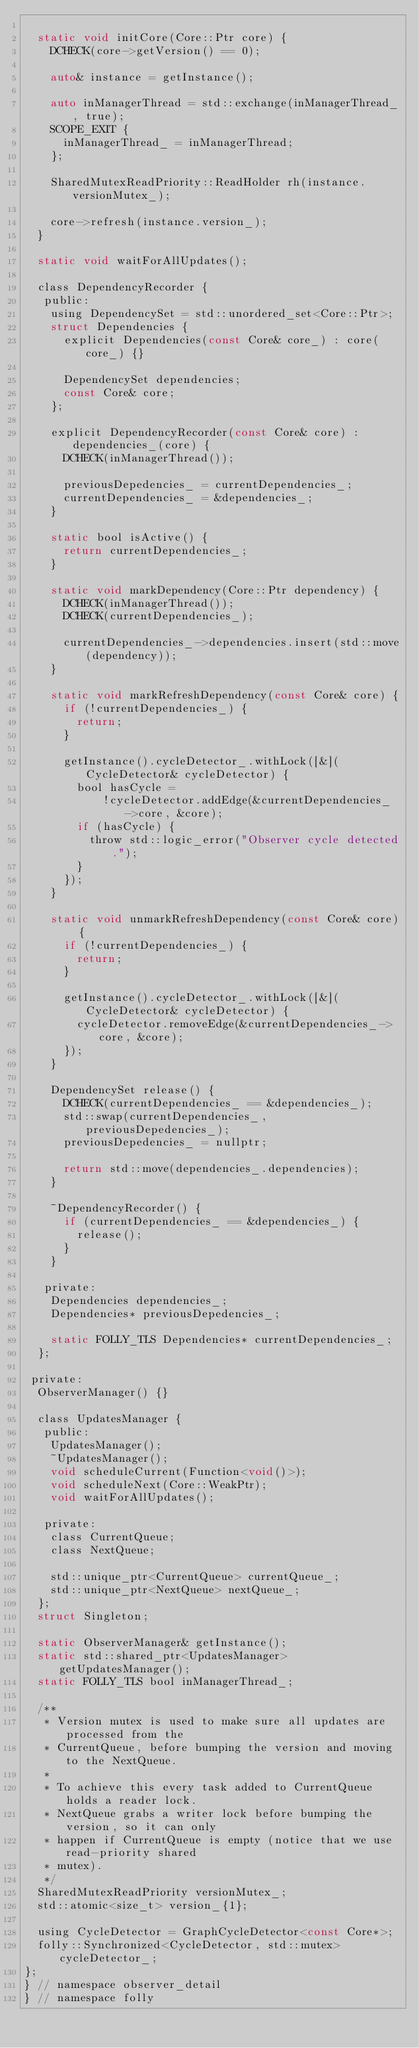Convert code to text. <code><loc_0><loc_0><loc_500><loc_500><_C_>
  static void initCore(Core::Ptr core) {
    DCHECK(core->getVersion() == 0);

    auto& instance = getInstance();

    auto inManagerThread = std::exchange(inManagerThread_, true);
    SCOPE_EXIT {
      inManagerThread_ = inManagerThread;
    };

    SharedMutexReadPriority::ReadHolder rh(instance.versionMutex_);

    core->refresh(instance.version_);
  }

  static void waitForAllUpdates();

  class DependencyRecorder {
   public:
    using DependencySet = std::unordered_set<Core::Ptr>;
    struct Dependencies {
      explicit Dependencies(const Core& core_) : core(core_) {}

      DependencySet dependencies;
      const Core& core;
    };

    explicit DependencyRecorder(const Core& core) : dependencies_(core) {
      DCHECK(inManagerThread());

      previousDepedencies_ = currentDependencies_;
      currentDependencies_ = &dependencies_;
    }

    static bool isActive() {
      return currentDependencies_;
    }

    static void markDependency(Core::Ptr dependency) {
      DCHECK(inManagerThread());
      DCHECK(currentDependencies_);

      currentDependencies_->dependencies.insert(std::move(dependency));
    }

    static void markRefreshDependency(const Core& core) {
      if (!currentDependencies_) {
        return;
      }

      getInstance().cycleDetector_.withLock([&](CycleDetector& cycleDetector) {
        bool hasCycle =
            !cycleDetector.addEdge(&currentDependencies_->core, &core);
        if (hasCycle) {
          throw std::logic_error("Observer cycle detected.");
        }
      });
    }

    static void unmarkRefreshDependency(const Core& core) {
      if (!currentDependencies_) {
        return;
      }

      getInstance().cycleDetector_.withLock([&](CycleDetector& cycleDetector) {
        cycleDetector.removeEdge(&currentDependencies_->core, &core);
      });
    }

    DependencySet release() {
      DCHECK(currentDependencies_ == &dependencies_);
      std::swap(currentDependencies_, previousDepedencies_);
      previousDepedencies_ = nullptr;

      return std::move(dependencies_.dependencies);
    }

    ~DependencyRecorder() {
      if (currentDependencies_ == &dependencies_) {
        release();
      }
    }

   private:
    Dependencies dependencies_;
    Dependencies* previousDepedencies_;

    static FOLLY_TLS Dependencies* currentDependencies_;
  };

 private:
  ObserverManager() {}

  class UpdatesManager {
   public:
    UpdatesManager();
    ~UpdatesManager();
    void scheduleCurrent(Function<void()>);
    void scheduleNext(Core::WeakPtr);
    void waitForAllUpdates();

   private:
    class CurrentQueue;
    class NextQueue;

    std::unique_ptr<CurrentQueue> currentQueue_;
    std::unique_ptr<NextQueue> nextQueue_;
  };
  struct Singleton;

  static ObserverManager& getInstance();
  static std::shared_ptr<UpdatesManager> getUpdatesManager();
  static FOLLY_TLS bool inManagerThread_;

  /**
   * Version mutex is used to make sure all updates are processed from the
   * CurrentQueue, before bumping the version and moving to the NextQueue.
   *
   * To achieve this every task added to CurrentQueue holds a reader lock.
   * NextQueue grabs a writer lock before bumping the version, so it can only
   * happen if CurrentQueue is empty (notice that we use read-priority shared
   * mutex).
   */
  SharedMutexReadPriority versionMutex_;
  std::atomic<size_t> version_{1};

  using CycleDetector = GraphCycleDetector<const Core*>;
  folly::Synchronized<CycleDetector, std::mutex> cycleDetector_;
};
} // namespace observer_detail
} // namespace folly
</code> 